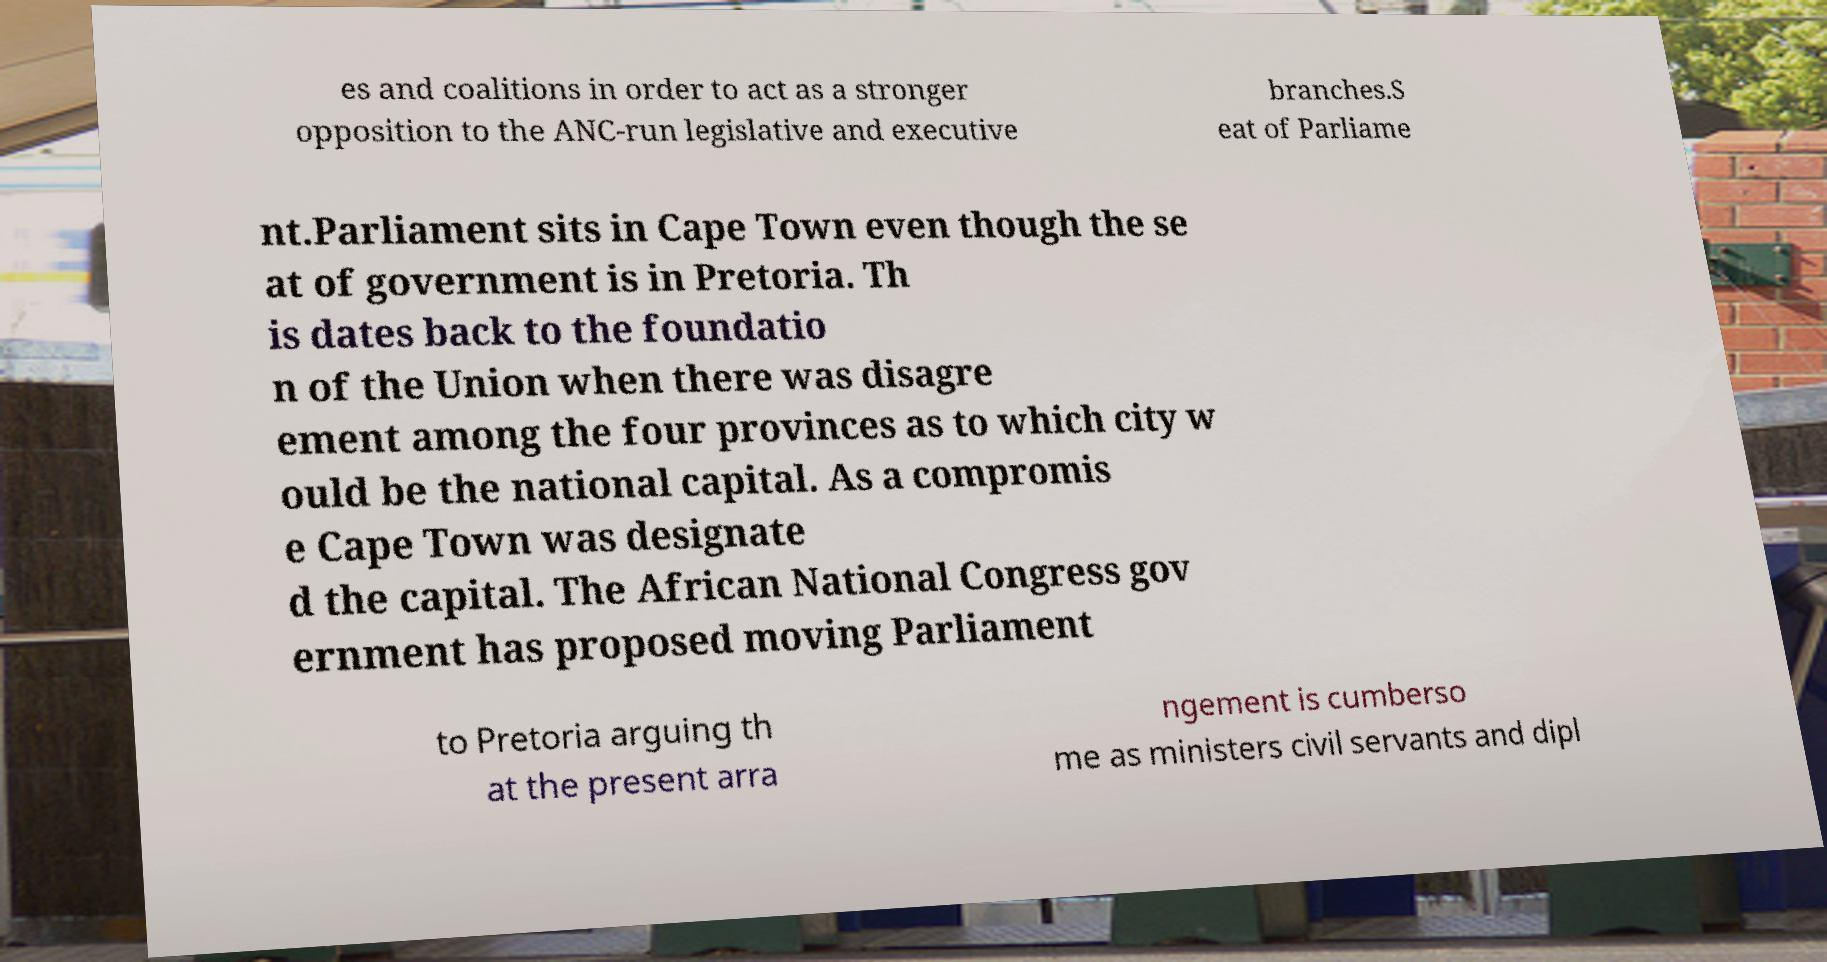For documentation purposes, I need the text within this image transcribed. Could you provide that? es and coalitions in order to act as a stronger opposition to the ANC-run legislative and executive branches.S eat of Parliame nt.Parliament sits in Cape Town even though the se at of government is in Pretoria. Th is dates back to the foundatio n of the Union when there was disagre ement among the four provinces as to which city w ould be the national capital. As a compromis e Cape Town was designate d the capital. The African National Congress gov ernment has proposed moving Parliament to Pretoria arguing th at the present arra ngement is cumberso me as ministers civil servants and dipl 